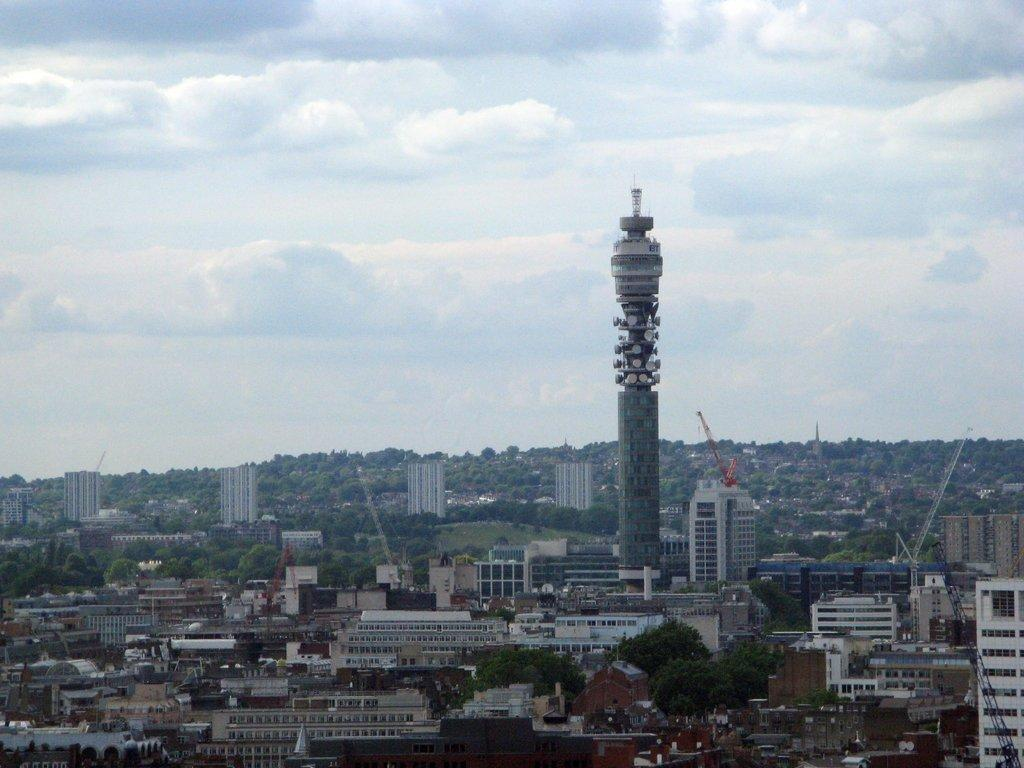What type of structures can be seen in the image? There are buildings in the image. What natural elements are present in the image? There are trees in the image. What construction equipment is visible in the image? There is a crane in the image. What tall structure can be seen in the image? There is a tower in the image. What is the weather like in the image? The sky is cloudy in the image. What type of beef is being prepared by the carpenter in the image? There is no beef or carpenter present in the image. What type of woodworking tools is the father using in the image? There is no father or woodworking tools present in the image. 